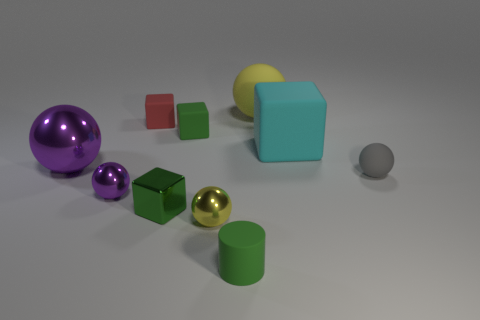There is a rubber ball right of the large ball that is on the right side of the tiny yellow object; how many yellow balls are in front of it? In the image, the rubber ball mentioned appears to be on the left side of the large ball, rather than the right. Additionally, there is no tiny yellow object present. Therefore, there are no yellow balls in front of the mentioned rubber ball because the premise of the question is based on an incorrect observation. 